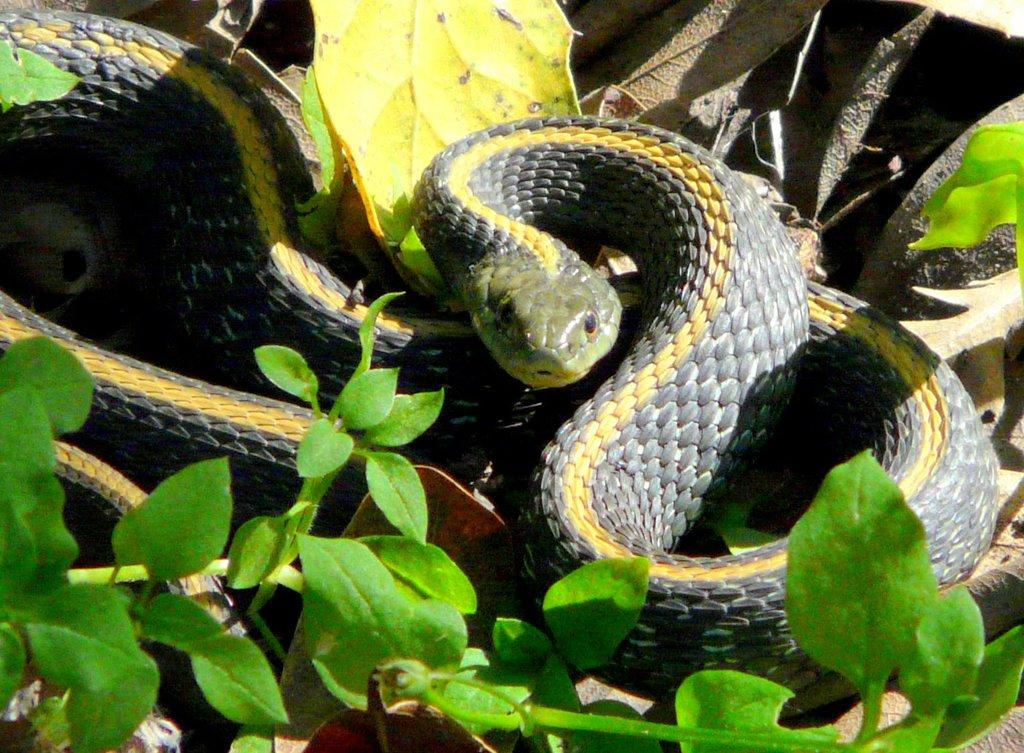What type of animals are present in the image? There are snakes in the image. What colors can be seen on the snakes? The snakes are in gray and yellow color. What type of vegetation is visible in the image? There are green leaves in the image. What type of seat can be seen in the image? There is no seat present in the image; it features snakes and green leaves. What hobbies do the snakes enjoy in the image? There is no information about the snakes' hobbies in the image. 